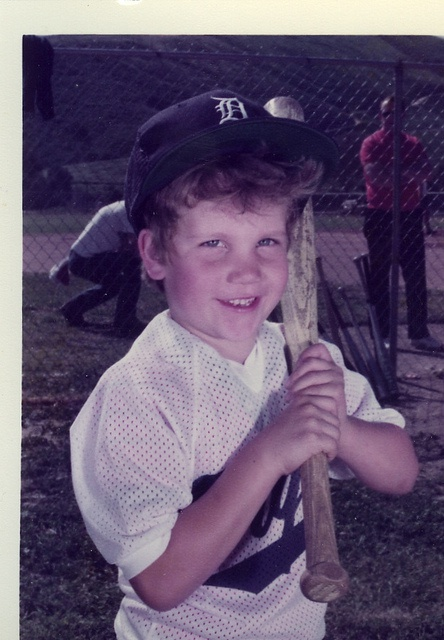Describe the objects in this image and their specific colors. I can see people in beige, darkgray, gray, navy, and purple tones, people in beige, navy, and purple tones, baseball bat in beige, purple, and gray tones, and people in beige, navy, purple, and darkgray tones in this image. 